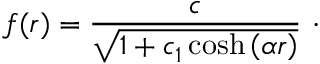<formula> <loc_0><loc_0><loc_500><loc_500>f ( r ) = \frac { c } { \sqrt { 1 + c _ { 1 } \cosh \left ( \alpha r \right ) } } \ \cdot</formula> 